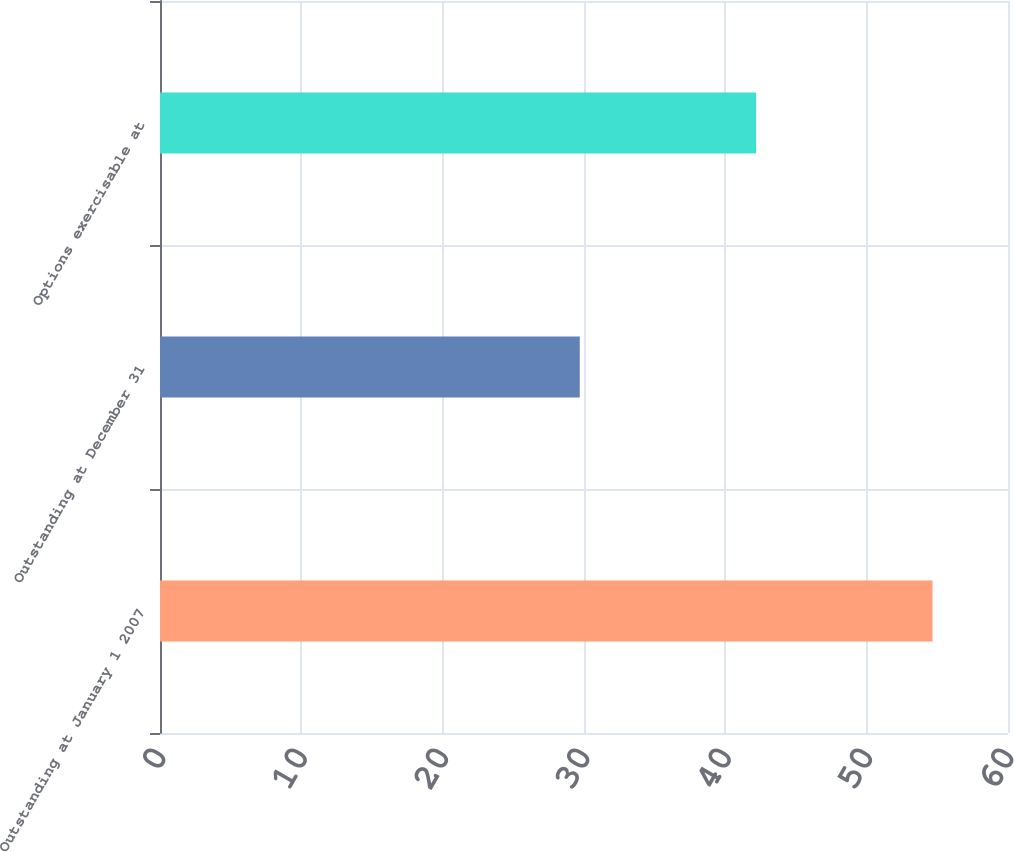Convert chart. <chart><loc_0><loc_0><loc_500><loc_500><bar_chart><fcel>Outstanding at January 1 2007<fcel>Outstanding at December 31<fcel>Options exercisable at<nl><fcel>54.66<fcel>29.7<fcel>42.18<nl></chart> 